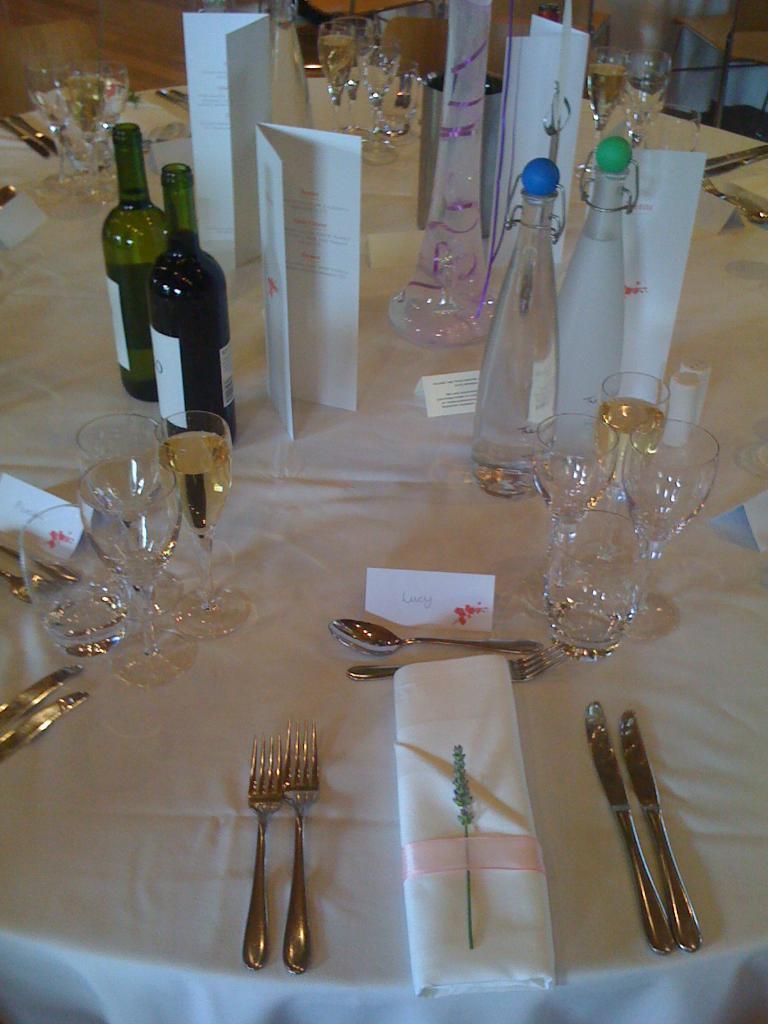Could you give a brief overview of what you see in this image? In the image we can see there is a table on which there are wine glasses, wine bottles, spoon, knife and kerchief. 